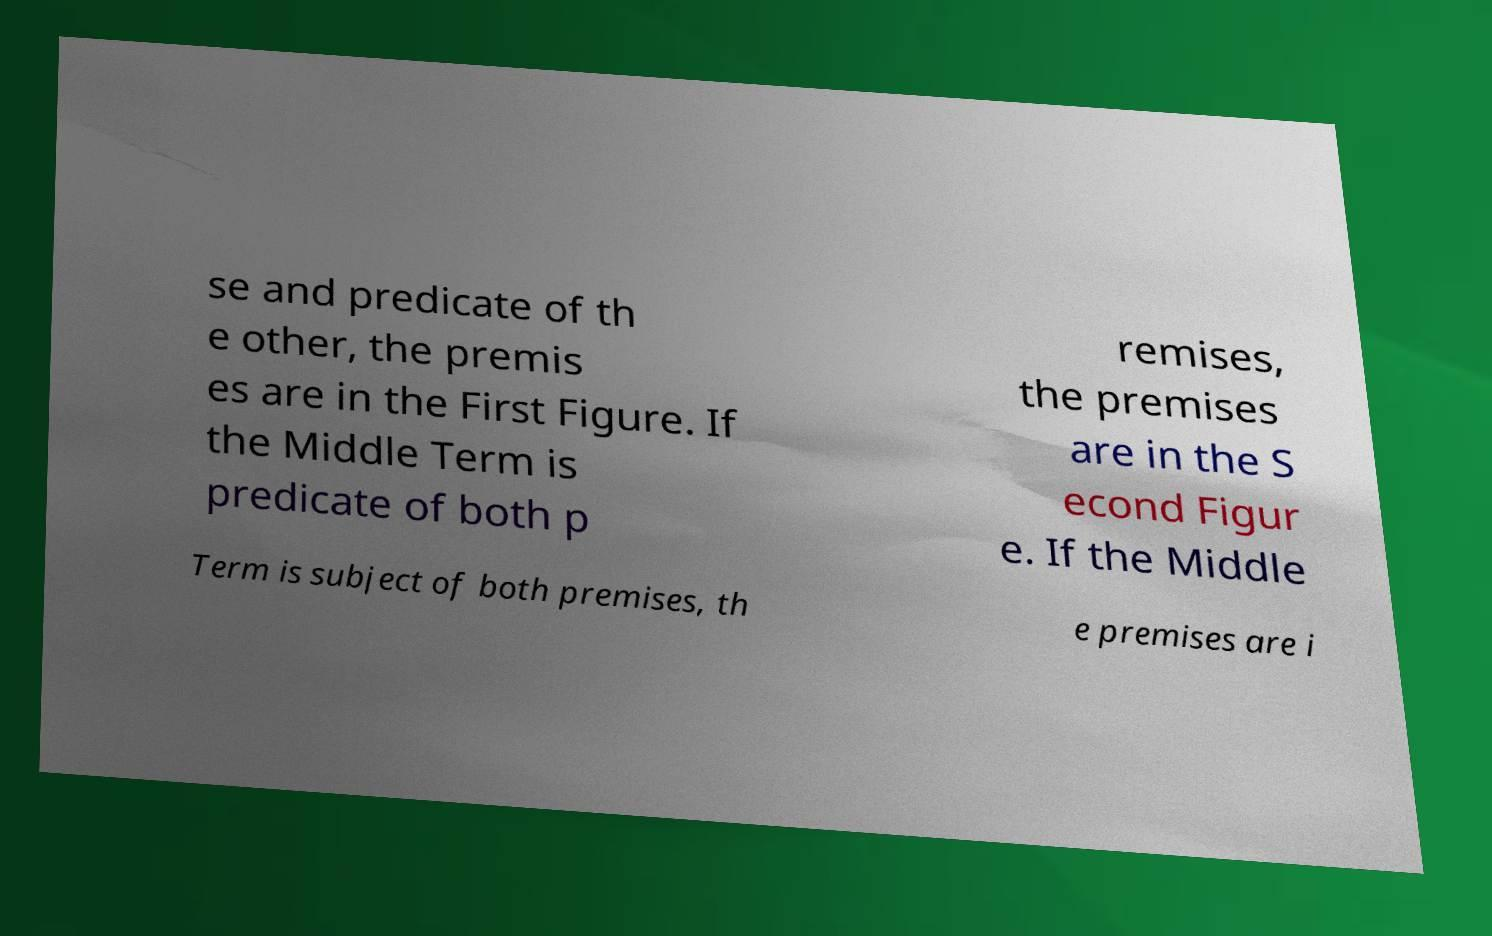Can you read and provide the text displayed in the image?This photo seems to have some interesting text. Can you extract and type it out for me? se and predicate of th e other, the premis es are in the First Figure. If the Middle Term is predicate of both p remises, the premises are in the S econd Figur e. If the Middle Term is subject of both premises, th e premises are i 